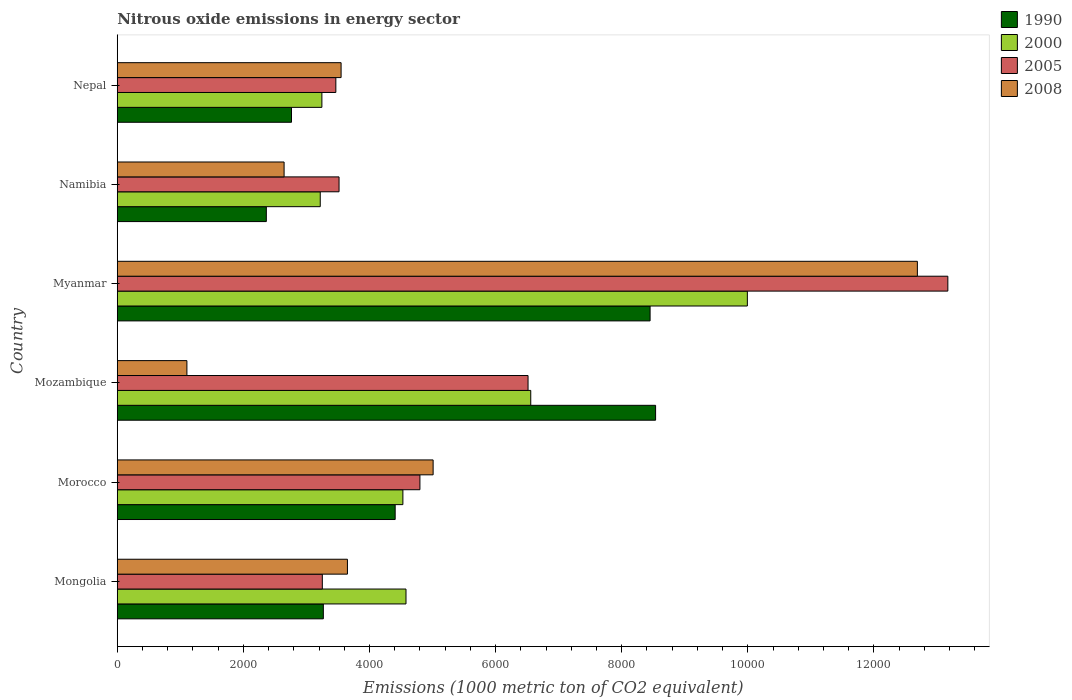How many different coloured bars are there?
Offer a terse response. 4. How many groups of bars are there?
Make the answer very short. 6. How many bars are there on the 5th tick from the top?
Your response must be concise. 4. How many bars are there on the 5th tick from the bottom?
Your answer should be compact. 4. What is the label of the 4th group of bars from the top?
Provide a short and direct response. Mozambique. What is the amount of nitrous oxide emitted in 2008 in Mozambique?
Provide a succinct answer. 1104.1. Across all countries, what is the maximum amount of nitrous oxide emitted in 2000?
Offer a very short reply. 9992.2. Across all countries, what is the minimum amount of nitrous oxide emitted in 2000?
Provide a succinct answer. 3218.7. In which country was the amount of nitrous oxide emitted in 1990 maximum?
Offer a terse response. Mozambique. In which country was the amount of nitrous oxide emitted in 1990 minimum?
Your answer should be very brief. Namibia. What is the total amount of nitrous oxide emitted in 2000 in the graph?
Your answer should be compact. 3.21e+04. What is the difference between the amount of nitrous oxide emitted in 2005 in Morocco and that in Myanmar?
Keep it short and to the point. -8372.2. What is the difference between the amount of nitrous oxide emitted in 2000 in Mozambique and the amount of nitrous oxide emitted in 1990 in Namibia?
Ensure brevity in your answer.  4193.4. What is the average amount of nitrous oxide emitted in 2008 per country?
Your answer should be compact. 4774.42. What is the difference between the amount of nitrous oxide emitted in 1990 and amount of nitrous oxide emitted in 2000 in Mongolia?
Your answer should be compact. -1310.8. In how many countries, is the amount of nitrous oxide emitted in 2005 greater than 8800 1000 metric ton?
Ensure brevity in your answer.  1. What is the ratio of the amount of nitrous oxide emitted in 2008 in Myanmar to that in Nepal?
Your answer should be compact. 3.57. Is the amount of nitrous oxide emitted in 1990 in Mongolia less than that in Namibia?
Give a very brief answer. No. What is the difference between the highest and the second highest amount of nitrous oxide emitted in 2008?
Offer a terse response. 7679.6. What is the difference between the highest and the lowest amount of nitrous oxide emitted in 1990?
Your response must be concise. 6173.2. Is the sum of the amount of nitrous oxide emitted in 1990 in Mozambique and Myanmar greater than the maximum amount of nitrous oxide emitted in 2008 across all countries?
Your response must be concise. Yes. Is it the case that in every country, the sum of the amount of nitrous oxide emitted in 1990 and amount of nitrous oxide emitted in 2005 is greater than the sum of amount of nitrous oxide emitted in 2000 and amount of nitrous oxide emitted in 2008?
Offer a terse response. No. What does the 4th bar from the top in Namibia represents?
Ensure brevity in your answer.  1990. How many bars are there?
Offer a terse response. 24. Are all the bars in the graph horizontal?
Your answer should be compact. Yes. Are the values on the major ticks of X-axis written in scientific E-notation?
Your answer should be compact. No. Does the graph contain any zero values?
Keep it short and to the point. No. How many legend labels are there?
Keep it short and to the point. 4. How are the legend labels stacked?
Provide a succinct answer. Vertical. What is the title of the graph?
Offer a terse response. Nitrous oxide emissions in energy sector. Does "1976" appear as one of the legend labels in the graph?
Keep it short and to the point. No. What is the label or title of the X-axis?
Provide a short and direct response. Emissions (1000 metric ton of CO2 equivalent). What is the label or title of the Y-axis?
Ensure brevity in your answer.  Country. What is the Emissions (1000 metric ton of CO2 equivalent) in 1990 in Mongolia?
Ensure brevity in your answer.  3267.8. What is the Emissions (1000 metric ton of CO2 equivalent) of 2000 in Mongolia?
Give a very brief answer. 4578.6. What is the Emissions (1000 metric ton of CO2 equivalent) in 2005 in Mongolia?
Give a very brief answer. 3251.9. What is the Emissions (1000 metric ton of CO2 equivalent) of 2008 in Mongolia?
Provide a succinct answer. 3650.1. What is the Emissions (1000 metric ton of CO2 equivalent) in 1990 in Morocco?
Provide a succinct answer. 4406.9. What is the Emissions (1000 metric ton of CO2 equivalent) in 2000 in Morocco?
Make the answer very short. 4529.5. What is the Emissions (1000 metric ton of CO2 equivalent) of 2005 in Morocco?
Your answer should be compact. 4799.4. What is the Emissions (1000 metric ton of CO2 equivalent) in 2008 in Morocco?
Your answer should be very brief. 5008.9. What is the Emissions (1000 metric ton of CO2 equivalent) of 1990 in Mozambique?
Offer a terse response. 8537. What is the Emissions (1000 metric ton of CO2 equivalent) in 2000 in Mozambique?
Your answer should be compact. 6557.2. What is the Emissions (1000 metric ton of CO2 equivalent) of 2005 in Mozambique?
Make the answer very short. 6514.2. What is the Emissions (1000 metric ton of CO2 equivalent) of 2008 in Mozambique?
Provide a short and direct response. 1104.1. What is the Emissions (1000 metric ton of CO2 equivalent) in 1990 in Myanmar?
Offer a very short reply. 8449.7. What is the Emissions (1000 metric ton of CO2 equivalent) of 2000 in Myanmar?
Offer a very short reply. 9992.2. What is the Emissions (1000 metric ton of CO2 equivalent) of 2005 in Myanmar?
Make the answer very short. 1.32e+04. What is the Emissions (1000 metric ton of CO2 equivalent) of 2008 in Myanmar?
Your response must be concise. 1.27e+04. What is the Emissions (1000 metric ton of CO2 equivalent) of 1990 in Namibia?
Keep it short and to the point. 2363.8. What is the Emissions (1000 metric ton of CO2 equivalent) of 2000 in Namibia?
Make the answer very short. 3218.7. What is the Emissions (1000 metric ton of CO2 equivalent) of 2005 in Namibia?
Offer a very short reply. 3516.8. What is the Emissions (1000 metric ton of CO2 equivalent) of 2008 in Namibia?
Make the answer very short. 2645.5. What is the Emissions (1000 metric ton of CO2 equivalent) of 1990 in Nepal?
Offer a very short reply. 2763. What is the Emissions (1000 metric ton of CO2 equivalent) in 2000 in Nepal?
Your response must be concise. 3244.8. What is the Emissions (1000 metric ton of CO2 equivalent) in 2005 in Nepal?
Your response must be concise. 3466.2. What is the Emissions (1000 metric ton of CO2 equivalent) of 2008 in Nepal?
Give a very brief answer. 3549.4. Across all countries, what is the maximum Emissions (1000 metric ton of CO2 equivalent) of 1990?
Provide a short and direct response. 8537. Across all countries, what is the maximum Emissions (1000 metric ton of CO2 equivalent) in 2000?
Offer a very short reply. 9992.2. Across all countries, what is the maximum Emissions (1000 metric ton of CO2 equivalent) in 2005?
Keep it short and to the point. 1.32e+04. Across all countries, what is the maximum Emissions (1000 metric ton of CO2 equivalent) of 2008?
Your answer should be very brief. 1.27e+04. Across all countries, what is the minimum Emissions (1000 metric ton of CO2 equivalent) of 1990?
Make the answer very short. 2363.8. Across all countries, what is the minimum Emissions (1000 metric ton of CO2 equivalent) in 2000?
Make the answer very short. 3218.7. Across all countries, what is the minimum Emissions (1000 metric ton of CO2 equivalent) in 2005?
Give a very brief answer. 3251.9. Across all countries, what is the minimum Emissions (1000 metric ton of CO2 equivalent) in 2008?
Provide a short and direct response. 1104.1. What is the total Emissions (1000 metric ton of CO2 equivalent) in 1990 in the graph?
Your response must be concise. 2.98e+04. What is the total Emissions (1000 metric ton of CO2 equivalent) of 2000 in the graph?
Provide a succinct answer. 3.21e+04. What is the total Emissions (1000 metric ton of CO2 equivalent) in 2005 in the graph?
Your response must be concise. 3.47e+04. What is the total Emissions (1000 metric ton of CO2 equivalent) of 2008 in the graph?
Your answer should be very brief. 2.86e+04. What is the difference between the Emissions (1000 metric ton of CO2 equivalent) in 1990 in Mongolia and that in Morocco?
Your answer should be compact. -1139.1. What is the difference between the Emissions (1000 metric ton of CO2 equivalent) of 2000 in Mongolia and that in Morocco?
Provide a succinct answer. 49.1. What is the difference between the Emissions (1000 metric ton of CO2 equivalent) in 2005 in Mongolia and that in Morocco?
Provide a short and direct response. -1547.5. What is the difference between the Emissions (1000 metric ton of CO2 equivalent) in 2008 in Mongolia and that in Morocco?
Offer a terse response. -1358.8. What is the difference between the Emissions (1000 metric ton of CO2 equivalent) in 1990 in Mongolia and that in Mozambique?
Make the answer very short. -5269.2. What is the difference between the Emissions (1000 metric ton of CO2 equivalent) in 2000 in Mongolia and that in Mozambique?
Offer a very short reply. -1978.6. What is the difference between the Emissions (1000 metric ton of CO2 equivalent) of 2005 in Mongolia and that in Mozambique?
Your answer should be very brief. -3262.3. What is the difference between the Emissions (1000 metric ton of CO2 equivalent) in 2008 in Mongolia and that in Mozambique?
Give a very brief answer. 2546. What is the difference between the Emissions (1000 metric ton of CO2 equivalent) of 1990 in Mongolia and that in Myanmar?
Keep it short and to the point. -5181.9. What is the difference between the Emissions (1000 metric ton of CO2 equivalent) of 2000 in Mongolia and that in Myanmar?
Provide a short and direct response. -5413.6. What is the difference between the Emissions (1000 metric ton of CO2 equivalent) in 2005 in Mongolia and that in Myanmar?
Your response must be concise. -9919.7. What is the difference between the Emissions (1000 metric ton of CO2 equivalent) in 2008 in Mongolia and that in Myanmar?
Make the answer very short. -9038.4. What is the difference between the Emissions (1000 metric ton of CO2 equivalent) in 1990 in Mongolia and that in Namibia?
Provide a succinct answer. 904. What is the difference between the Emissions (1000 metric ton of CO2 equivalent) in 2000 in Mongolia and that in Namibia?
Provide a short and direct response. 1359.9. What is the difference between the Emissions (1000 metric ton of CO2 equivalent) in 2005 in Mongolia and that in Namibia?
Your answer should be compact. -264.9. What is the difference between the Emissions (1000 metric ton of CO2 equivalent) of 2008 in Mongolia and that in Namibia?
Your answer should be compact. 1004.6. What is the difference between the Emissions (1000 metric ton of CO2 equivalent) in 1990 in Mongolia and that in Nepal?
Give a very brief answer. 504.8. What is the difference between the Emissions (1000 metric ton of CO2 equivalent) of 2000 in Mongolia and that in Nepal?
Your response must be concise. 1333.8. What is the difference between the Emissions (1000 metric ton of CO2 equivalent) of 2005 in Mongolia and that in Nepal?
Offer a very short reply. -214.3. What is the difference between the Emissions (1000 metric ton of CO2 equivalent) in 2008 in Mongolia and that in Nepal?
Provide a succinct answer. 100.7. What is the difference between the Emissions (1000 metric ton of CO2 equivalent) in 1990 in Morocco and that in Mozambique?
Keep it short and to the point. -4130.1. What is the difference between the Emissions (1000 metric ton of CO2 equivalent) of 2000 in Morocco and that in Mozambique?
Keep it short and to the point. -2027.7. What is the difference between the Emissions (1000 metric ton of CO2 equivalent) of 2005 in Morocco and that in Mozambique?
Keep it short and to the point. -1714.8. What is the difference between the Emissions (1000 metric ton of CO2 equivalent) of 2008 in Morocco and that in Mozambique?
Give a very brief answer. 3904.8. What is the difference between the Emissions (1000 metric ton of CO2 equivalent) of 1990 in Morocco and that in Myanmar?
Provide a short and direct response. -4042.8. What is the difference between the Emissions (1000 metric ton of CO2 equivalent) of 2000 in Morocco and that in Myanmar?
Provide a short and direct response. -5462.7. What is the difference between the Emissions (1000 metric ton of CO2 equivalent) of 2005 in Morocco and that in Myanmar?
Your answer should be compact. -8372.2. What is the difference between the Emissions (1000 metric ton of CO2 equivalent) in 2008 in Morocco and that in Myanmar?
Your response must be concise. -7679.6. What is the difference between the Emissions (1000 metric ton of CO2 equivalent) in 1990 in Morocco and that in Namibia?
Provide a succinct answer. 2043.1. What is the difference between the Emissions (1000 metric ton of CO2 equivalent) in 2000 in Morocco and that in Namibia?
Provide a short and direct response. 1310.8. What is the difference between the Emissions (1000 metric ton of CO2 equivalent) in 2005 in Morocco and that in Namibia?
Your answer should be compact. 1282.6. What is the difference between the Emissions (1000 metric ton of CO2 equivalent) of 2008 in Morocco and that in Namibia?
Make the answer very short. 2363.4. What is the difference between the Emissions (1000 metric ton of CO2 equivalent) in 1990 in Morocco and that in Nepal?
Provide a short and direct response. 1643.9. What is the difference between the Emissions (1000 metric ton of CO2 equivalent) of 2000 in Morocco and that in Nepal?
Keep it short and to the point. 1284.7. What is the difference between the Emissions (1000 metric ton of CO2 equivalent) of 2005 in Morocco and that in Nepal?
Your answer should be very brief. 1333.2. What is the difference between the Emissions (1000 metric ton of CO2 equivalent) of 2008 in Morocco and that in Nepal?
Your answer should be compact. 1459.5. What is the difference between the Emissions (1000 metric ton of CO2 equivalent) in 1990 in Mozambique and that in Myanmar?
Give a very brief answer. 87.3. What is the difference between the Emissions (1000 metric ton of CO2 equivalent) in 2000 in Mozambique and that in Myanmar?
Make the answer very short. -3435. What is the difference between the Emissions (1000 metric ton of CO2 equivalent) in 2005 in Mozambique and that in Myanmar?
Make the answer very short. -6657.4. What is the difference between the Emissions (1000 metric ton of CO2 equivalent) of 2008 in Mozambique and that in Myanmar?
Your answer should be compact. -1.16e+04. What is the difference between the Emissions (1000 metric ton of CO2 equivalent) in 1990 in Mozambique and that in Namibia?
Offer a very short reply. 6173.2. What is the difference between the Emissions (1000 metric ton of CO2 equivalent) in 2000 in Mozambique and that in Namibia?
Keep it short and to the point. 3338.5. What is the difference between the Emissions (1000 metric ton of CO2 equivalent) of 2005 in Mozambique and that in Namibia?
Offer a very short reply. 2997.4. What is the difference between the Emissions (1000 metric ton of CO2 equivalent) in 2008 in Mozambique and that in Namibia?
Ensure brevity in your answer.  -1541.4. What is the difference between the Emissions (1000 metric ton of CO2 equivalent) in 1990 in Mozambique and that in Nepal?
Offer a very short reply. 5774. What is the difference between the Emissions (1000 metric ton of CO2 equivalent) in 2000 in Mozambique and that in Nepal?
Offer a very short reply. 3312.4. What is the difference between the Emissions (1000 metric ton of CO2 equivalent) of 2005 in Mozambique and that in Nepal?
Your response must be concise. 3048. What is the difference between the Emissions (1000 metric ton of CO2 equivalent) of 2008 in Mozambique and that in Nepal?
Ensure brevity in your answer.  -2445.3. What is the difference between the Emissions (1000 metric ton of CO2 equivalent) in 1990 in Myanmar and that in Namibia?
Ensure brevity in your answer.  6085.9. What is the difference between the Emissions (1000 metric ton of CO2 equivalent) of 2000 in Myanmar and that in Namibia?
Keep it short and to the point. 6773.5. What is the difference between the Emissions (1000 metric ton of CO2 equivalent) in 2005 in Myanmar and that in Namibia?
Provide a short and direct response. 9654.8. What is the difference between the Emissions (1000 metric ton of CO2 equivalent) in 2008 in Myanmar and that in Namibia?
Offer a very short reply. 1.00e+04. What is the difference between the Emissions (1000 metric ton of CO2 equivalent) in 1990 in Myanmar and that in Nepal?
Your answer should be very brief. 5686.7. What is the difference between the Emissions (1000 metric ton of CO2 equivalent) of 2000 in Myanmar and that in Nepal?
Offer a very short reply. 6747.4. What is the difference between the Emissions (1000 metric ton of CO2 equivalent) of 2005 in Myanmar and that in Nepal?
Give a very brief answer. 9705.4. What is the difference between the Emissions (1000 metric ton of CO2 equivalent) of 2008 in Myanmar and that in Nepal?
Your answer should be compact. 9139.1. What is the difference between the Emissions (1000 metric ton of CO2 equivalent) in 1990 in Namibia and that in Nepal?
Your response must be concise. -399.2. What is the difference between the Emissions (1000 metric ton of CO2 equivalent) of 2000 in Namibia and that in Nepal?
Keep it short and to the point. -26.1. What is the difference between the Emissions (1000 metric ton of CO2 equivalent) in 2005 in Namibia and that in Nepal?
Offer a terse response. 50.6. What is the difference between the Emissions (1000 metric ton of CO2 equivalent) in 2008 in Namibia and that in Nepal?
Your answer should be very brief. -903.9. What is the difference between the Emissions (1000 metric ton of CO2 equivalent) in 1990 in Mongolia and the Emissions (1000 metric ton of CO2 equivalent) in 2000 in Morocco?
Your answer should be compact. -1261.7. What is the difference between the Emissions (1000 metric ton of CO2 equivalent) in 1990 in Mongolia and the Emissions (1000 metric ton of CO2 equivalent) in 2005 in Morocco?
Keep it short and to the point. -1531.6. What is the difference between the Emissions (1000 metric ton of CO2 equivalent) in 1990 in Mongolia and the Emissions (1000 metric ton of CO2 equivalent) in 2008 in Morocco?
Offer a very short reply. -1741.1. What is the difference between the Emissions (1000 metric ton of CO2 equivalent) of 2000 in Mongolia and the Emissions (1000 metric ton of CO2 equivalent) of 2005 in Morocco?
Provide a succinct answer. -220.8. What is the difference between the Emissions (1000 metric ton of CO2 equivalent) in 2000 in Mongolia and the Emissions (1000 metric ton of CO2 equivalent) in 2008 in Morocco?
Offer a very short reply. -430.3. What is the difference between the Emissions (1000 metric ton of CO2 equivalent) in 2005 in Mongolia and the Emissions (1000 metric ton of CO2 equivalent) in 2008 in Morocco?
Your answer should be very brief. -1757. What is the difference between the Emissions (1000 metric ton of CO2 equivalent) of 1990 in Mongolia and the Emissions (1000 metric ton of CO2 equivalent) of 2000 in Mozambique?
Make the answer very short. -3289.4. What is the difference between the Emissions (1000 metric ton of CO2 equivalent) in 1990 in Mongolia and the Emissions (1000 metric ton of CO2 equivalent) in 2005 in Mozambique?
Keep it short and to the point. -3246.4. What is the difference between the Emissions (1000 metric ton of CO2 equivalent) of 1990 in Mongolia and the Emissions (1000 metric ton of CO2 equivalent) of 2008 in Mozambique?
Provide a succinct answer. 2163.7. What is the difference between the Emissions (1000 metric ton of CO2 equivalent) of 2000 in Mongolia and the Emissions (1000 metric ton of CO2 equivalent) of 2005 in Mozambique?
Give a very brief answer. -1935.6. What is the difference between the Emissions (1000 metric ton of CO2 equivalent) in 2000 in Mongolia and the Emissions (1000 metric ton of CO2 equivalent) in 2008 in Mozambique?
Offer a terse response. 3474.5. What is the difference between the Emissions (1000 metric ton of CO2 equivalent) in 2005 in Mongolia and the Emissions (1000 metric ton of CO2 equivalent) in 2008 in Mozambique?
Offer a very short reply. 2147.8. What is the difference between the Emissions (1000 metric ton of CO2 equivalent) of 1990 in Mongolia and the Emissions (1000 metric ton of CO2 equivalent) of 2000 in Myanmar?
Provide a succinct answer. -6724.4. What is the difference between the Emissions (1000 metric ton of CO2 equivalent) of 1990 in Mongolia and the Emissions (1000 metric ton of CO2 equivalent) of 2005 in Myanmar?
Ensure brevity in your answer.  -9903.8. What is the difference between the Emissions (1000 metric ton of CO2 equivalent) in 1990 in Mongolia and the Emissions (1000 metric ton of CO2 equivalent) in 2008 in Myanmar?
Provide a succinct answer. -9420.7. What is the difference between the Emissions (1000 metric ton of CO2 equivalent) of 2000 in Mongolia and the Emissions (1000 metric ton of CO2 equivalent) of 2005 in Myanmar?
Your response must be concise. -8593. What is the difference between the Emissions (1000 metric ton of CO2 equivalent) of 2000 in Mongolia and the Emissions (1000 metric ton of CO2 equivalent) of 2008 in Myanmar?
Your response must be concise. -8109.9. What is the difference between the Emissions (1000 metric ton of CO2 equivalent) of 2005 in Mongolia and the Emissions (1000 metric ton of CO2 equivalent) of 2008 in Myanmar?
Make the answer very short. -9436.6. What is the difference between the Emissions (1000 metric ton of CO2 equivalent) of 1990 in Mongolia and the Emissions (1000 metric ton of CO2 equivalent) of 2000 in Namibia?
Offer a very short reply. 49.1. What is the difference between the Emissions (1000 metric ton of CO2 equivalent) of 1990 in Mongolia and the Emissions (1000 metric ton of CO2 equivalent) of 2005 in Namibia?
Provide a short and direct response. -249. What is the difference between the Emissions (1000 metric ton of CO2 equivalent) in 1990 in Mongolia and the Emissions (1000 metric ton of CO2 equivalent) in 2008 in Namibia?
Your answer should be compact. 622.3. What is the difference between the Emissions (1000 metric ton of CO2 equivalent) in 2000 in Mongolia and the Emissions (1000 metric ton of CO2 equivalent) in 2005 in Namibia?
Offer a terse response. 1061.8. What is the difference between the Emissions (1000 metric ton of CO2 equivalent) of 2000 in Mongolia and the Emissions (1000 metric ton of CO2 equivalent) of 2008 in Namibia?
Ensure brevity in your answer.  1933.1. What is the difference between the Emissions (1000 metric ton of CO2 equivalent) in 2005 in Mongolia and the Emissions (1000 metric ton of CO2 equivalent) in 2008 in Namibia?
Your answer should be very brief. 606.4. What is the difference between the Emissions (1000 metric ton of CO2 equivalent) in 1990 in Mongolia and the Emissions (1000 metric ton of CO2 equivalent) in 2000 in Nepal?
Offer a terse response. 23. What is the difference between the Emissions (1000 metric ton of CO2 equivalent) in 1990 in Mongolia and the Emissions (1000 metric ton of CO2 equivalent) in 2005 in Nepal?
Ensure brevity in your answer.  -198.4. What is the difference between the Emissions (1000 metric ton of CO2 equivalent) of 1990 in Mongolia and the Emissions (1000 metric ton of CO2 equivalent) of 2008 in Nepal?
Keep it short and to the point. -281.6. What is the difference between the Emissions (1000 metric ton of CO2 equivalent) of 2000 in Mongolia and the Emissions (1000 metric ton of CO2 equivalent) of 2005 in Nepal?
Make the answer very short. 1112.4. What is the difference between the Emissions (1000 metric ton of CO2 equivalent) of 2000 in Mongolia and the Emissions (1000 metric ton of CO2 equivalent) of 2008 in Nepal?
Keep it short and to the point. 1029.2. What is the difference between the Emissions (1000 metric ton of CO2 equivalent) of 2005 in Mongolia and the Emissions (1000 metric ton of CO2 equivalent) of 2008 in Nepal?
Ensure brevity in your answer.  -297.5. What is the difference between the Emissions (1000 metric ton of CO2 equivalent) of 1990 in Morocco and the Emissions (1000 metric ton of CO2 equivalent) of 2000 in Mozambique?
Your answer should be very brief. -2150.3. What is the difference between the Emissions (1000 metric ton of CO2 equivalent) in 1990 in Morocco and the Emissions (1000 metric ton of CO2 equivalent) in 2005 in Mozambique?
Your response must be concise. -2107.3. What is the difference between the Emissions (1000 metric ton of CO2 equivalent) in 1990 in Morocco and the Emissions (1000 metric ton of CO2 equivalent) in 2008 in Mozambique?
Your response must be concise. 3302.8. What is the difference between the Emissions (1000 metric ton of CO2 equivalent) in 2000 in Morocco and the Emissions (1000 metric ton of CO2 equivalent) in 2005 in Mozambique?
Offer a terse response. -1984.7. What is the difference between the Emissions (1000 metric ton of CO2 equivalent) in 2000 in Morocco and the Emissions (1000 metric ton of CO2 equivalent) in 2008 in Mozambique?
Offer a terse response. 3425.4. What is the difference between the Emissions (1000 metric ton of CO2 equivalent) of 2005 in Morocco and the Emissions (1000 metric ton of CO2 equivalent) of 2008 in Mozambique?
Your answer should be compact. 3695.3. What is the difference between the Emissions (1000 metric ton of CO2 equivalent) of 1990 in Morocco and the Emissions (1000 metric ton of CO2 equivalent) of 2000 in Myanmar?
Provide a succinct answer. -5585.3. What is the difference between the Emissions (1000 metric ton of CO2 equivalent) in 1990 in Morocco and the Emissions (1000 metric ton of CO2 equivalent) in 2005 in Myanmar?
Offer a very short reply. -8764.7. What is the difference between the Emissions (1000 metric ton of CO2 equivalent) of 1990 in Morocco and the Emissions (1000 metric ton of CO2 equivalent) of 2008 in Myanmar?
Offer a very short reply. -8281.6. What is the difference between the Emissions (1000 metric ton of CO2 equivalent) in 2000 in Morocco and the Emissions (1000 metric ton of CO2 equivalent) in 2005 in Myanmar?
Provide a succinct answer. -8642.1. What is the difference between the Emissions (1000 metric ton of CO2 equivalent) of 2000 in Morocco and the Emissions (1000 metric ton of CO2 equivalent) of 2008 in Myanmar?
Your answer should be compact. -8159. What is the difference between the Emissions (1000 metric ton of CO2 equivalent) in 2005 in Morocco and the Emissions (1000 metric ton of CO2 equivalent) in 2008 in Myanmar?
Provide a short and direct response. -7889.1. What is the difference between the Emissions (1000 metric ton of CO2 equivalent) in 1990 in Morocco and the Emissions (1000 metric ton of CO2 equivalent) in 2000 in Namibia?
Your response must be concise. 1188.2. What is the difference between the Emissions (1000 metric ton of CO2 equivalent) of 1990 in Morocco and the Emissions (1000 metric ton of CO2 equivalent) of 2005 in Namibia?
Offer a terse response. 890.1. What is the difference between the Emissions (1000 metric ton of CO2 equivalent) in 1990 in Morocco and the Emissions (1000 metric ton of CO2 equivalent) in 2008 in Namibia?
Offer a very short reply. 1761.4. What is the difference between the Emissions (1000 metric ton of CO2 equivalent) of 2000 in Morocco and the Emissions (1000 metric ton of CO2 equivalent) of 2005 in Namibia?
Provide a short and direct response. 1012.7. What is the difference between the Emissions (1000 metric ton of CO2 equivalent) in 2000 in Morocco and the Emissions (1000 metric ton of CO2 equivalent) in 2008 in Namibia?
Offer a terse response. 1884. What is the difference between the Emissions (1000 metric ton of CO2 equivalent) in 2005 in Morocco and the Emissions (1000 metric ton of CO2 equivalent) in 2008 in Namibia?
Make the answer very short. 2153.9. What is the difference between the Emissions (1000 metric ton of CO2 equivalent) of 1990 in Morocco and the Emissions (1000 metric ton of CO2 equivalent) of 2000 in Nepal?
Your answer should be very brief. 1162.1. What is the difference between the Emissions (1000 metric ton of CO2 equivalent) of 1990 in Morocco and the Emissions (1000 metric ton of CO2 equivalent) of 2005 in Nepal?
Keep it short and to the point. 940.7. What is the difference between the Emissions (1000 metric ton of CO2 equivalent) in 1990 in Morocco and the Emissions (1000 metric ton of CO2 equivalent) in 2008 in Nepal?
Make the answer very short. 857.5. What is the difference between the Emissions (1000 metric ton of CO2 equivalent) of 2000 in Morocco and the Emissions (1000 metric ton of CO2 equivalent) of 2005 in Nepal?
Provide a short and direct response. 1063.3. What is the difference between the Emissions (1000 metric ton of CO2 equivalent) of 2000 in Morocco and the Emissions (1000 metric ton of CO2 equivalent) of 2008 in Nepal?
Offer a very short reply. 980.1. What is the difference between the Emissions (1000 metric ton of CO2 equivalent) in 2005 in Morocco and the Emissions (1000 metric ton of CO2 equivalent) in 2008 in Nepal?
Your answer should be very brief. 1250. What is the difference between the Emissions (1000 metric ton of CO2 equivalent) in 1990 in Mozambique and the Emissions (1000 metric ton of CO2 equivalent) in 2000 in Myanmar?
Your answer should be compact. -1455.2. What is the difference between the Emissions (1000 metric ton of CO2 equivalent) in 1990 in Mozambique and the Emissions (1000 metric ton of CO2 equivalent) in 2005 in Myanmar?
Your response must be concise. -4634.6. What is the difference between the Emissions (1000 metric ton of CO2 equivalent) of 1990 in Mozambique and the Emissions (1000 metric ton of CO2 equivalent) of 2008 in Myanmar?
Make the answer very short. -4151.5. What is the difference between the Emissions (1000 metric ton of CO2 equivalent) in 2000 in Mozambique and the Emissions (1000 metric ton of CO2 equivalent) in 2005 in Myanmar?
Your response must be concise. -6614.4. What is the difference between the Emissions (1000 metric ton of CO2 equivalent) of 2000 in Mozambique and the Emissions (1000 metric ton of CO2 equivalent) of 2008 in Myanmar?
Make the answer very short. -6131.3. What is the difference between the Emissions (1000 metric ton of CO2 equivalent) of 2005 in Mozambique and the Emissions (1000 metric ton of CO2 equivalent) of 2008 in Myanmar?
Offer a terse response. -6174.3. What is the difference between the Emissions (1000 metric ton of CO2 equivalent) of 1990 in Mozambique and the Emissions (1000 metric ton of CO2 equivalent) of 2000 in Namibia?
Your response must be concise. 5318.3. What is the difference between the Emissions (1000 metric ton of CO2 equivalent) of 1990 in Mozambique and the Emissions (1000 metric ton of CO2 equivalent) of 2005 in Namibia?
Your answer should be very brief. 5020.2. What is the difference between the Emissions (1000 metric ton of CO2 equivalent) of 1990 in Mozambique and the Emissions (1000 metric ton of CO2 equivalent) of 2008 in Namibia?
Offer a terse response. 5891.5. What is the difference between the Emissions (1000 metric ton of CO2 equivalent) in 2000 in Mozambique and the Emissions (1000 metric ton of CO2 equivalent) in 2005 in Namibia?
Your response must be concise. 3040.4. What is the difference between the Emissions (1000 metric ton of CO2 equivalent) of 2000 in Mozambique and the Emissions (1000 metric ton of CO2 equivalent) of 2008 in Namibia?
Your response must be concise. 3911.7. What is the difference between the Emissions (1000 metric ton of CO2 equivalent) in 2005 in Mozambique and the Emissions (1000 metric ton of CO2 equivalent) in 2008 in Namibia?
Your response must be concise. 3868.7. What is the difference between the Emissions (1000 metric ton of CO2 equivalent) of 1990 in Mozambique and the Emissions (1000 metric ton of CO2 equivalent) of 2000 in Nepal?
Provide a short and direct response. 5292.2. What is the difference between the Emissions (1000 metric ton of CO2 equivalent) in 1990 in Mozambique and the Emissions (1000 metric ton of CO2 equivalent) in 2005 in Nepal?
Your answer should be compact. 5070.8. What is the difference between the Emissions (1000 metric ton of CO2 equivalent) in 1990 in Mozambique and the Emissions (1000 metric ton of CO2 equivalent) in 2008 in Nepal?
Your answer should be very brief. 4987.6. What is the difference between the Emissions (1000 metric ton of CO2 equivalent) in 2000 in Mozambique and the Emissions (1000 metric ton of CO2 equivalent) in 2005 in Nepal?
Ensure brevity in your answer.  3091. What is the difference between the Emissions (1000 metric ton of CO2 equivalent) in 2000 in Mozambique and the Emissions (1000 metric ton of CO2 equivalent) in 2008 in Nepal?
Offer a terse response. 3007.8. What is the difference between the Emissions (1000 metric ton of CO2 equivalent) of 2005 in Mozambique and the Emissions (1000 metric ton of CO2 equivalent) of 2008 in Nepal?
Provide a short and direct response. 2964.8. What is the difference between the Emissions (1000 metric ton of CO2 equivalent) in 1990 in Myanmar and the Emissions (1000 metric ton of CO2 equivalent) in 2000 in Namibia?
Ensure brevity in your answer.  5231. What is the difference between the Emissions (1000 metric ton of CO2 equivalent) in 1990 in Myanmar and the Emissions (1000 metric ton of CO2 equivalent) in 2005 in Namibia?
Ensure brevity in your answer.  4932.9. What is the difference between the Emissions (1000 metric ton of CO2 equivalent) of 1990 in Myanmar and the Emissions (1000 metric ton of CO2 equivalent) of 2008 in Namibia?
Make the answer very short. 5804.2. What is the difference between the Emissions (1000 metric ton of CO2 equivalent) of 2000 in Myanmar and the Emissions (1000 metric ton of CO2 equivalent) of 2005 in Namibia?
Your answer should be compact. 6475.4. What is the difference between the Emissions (1000 metric ton of CO2 equivalent) in 2000 in Myanmar and the Emissions (1000 metric ton of CO2 equivalent) in 2008 in Namibia?
Provide a succinct answer. 7346.7. What is the difference between the Emissions (1000 metric ton of CO2 equivalent) of 2005 in Myanmar and the Emissions (1000 metric ton of CO2 equivalent) of 2008 in Namibia?
Make the answer very short. 1.05e+04. What is the difference between the Emissions (1000 metric ton of CO2 equivalent) of 1990 in Myanmar and the Emissions (1000 metric ton of CO2 equivalent) of 2000 in Nepal?
Make the answer very short. 5204.9. What is the difference between the Emissions (1000 metric ton of CO2 equivalent) of 1990 in Myanmar and the Emissions (1000 metric ton of CO2 equivalent) of 2005 in Nepal?
Give a very brief answer. 4983.5. What is the difference between the Emissions (1000 metric ton of CO2 equivalent) of 1990 in Myanmar and the Emissions (1000 metric ton of CO2 equivalent) of 2008 in Nepal?
Offer a very short reply. 4900.3. What is the difference between the Emissions (1000 metric ton of CO2 equivalent) in 2000 in Myanmar and the Emissions (1000 metric ton of CO2 equivalent) in 2005 in Nepal?
Offer a terse response. 6526. What is the difference between the Emissions (1000 metric ton of CO2 equivalent) in 2000 in Myanmar and the Emissions (1000 metric ton of CO2 equivalent) in 2008 in Nepal?
Your response must be concise. 6442.8. What is the difference between the Emissions (1000 metric ton of CO2 equivalent) of 2005 in Myanmar and the Emissions (1000 metric ton of CO2 equivalent) of 2008 in Nepal?
Ensure brevity in your answer.  9622.2. What is the difference between the Emissions (1000 metric ton of CO2 equivalent) of 1990 in Namibia and the Emissions (1000 metric ton of CO2 equivalent) of 2000 in Nepal?
Provide a succinct answer. -881. What is the difference between the Emissions (1000 metric ton of CO2 equivalent) in 1990 in Namibia and the Emissions (1000 metric ton of CO2 equivalent) in 2005 in Nepal?
Give a very brief answer. -1102.4. What is the difference between the Emissions (1000 metric ton of CO2 equivalent) of 1990 in Namibia and the Emissions (1000 metric ton of CO2 equivalent) of 2008 in Nepal?
Offer a terse response. -1185.6. What is the difference between the Emissions (1000 metric ton of CO2 equivalent) in 2000 in Namibia and the Emissions (1000 metric ton of CO2 equivalent) in 2005 in Nepal?
Your answer should be compact. -247.5. What is the difference between the Emissions (1000 metric ton of CO2 equivalent) of 2000 in Namibia and the Emissions (1000 metric ton of CO2 equivalent) of 2008 in Nepal?
Provide a succinct answer. -330.7. What is the difference between the Emissions (1000 metric ton of CO2 equivalent) in 2005 in Namibia and the Emissions (1000 metric ton of CO2 equivalent) in 2008 in Nepal?
Give a very brief answer. -32.6. What is the average Emissions (1000 metric ton of CO2 equivalent) in 1990 per country?
Give a very brief answer. 4964.7. What is the average Emissions (1000 metric ton of CO2 equivalent) of 2000 per country?
Keep it short and to the point. 5353.5. What is the average Emissions (1000 metric ton of CO2 equivalent) in 2005 per country?
Your answer should be compact. 5786.68. What is the average Emissions (1000 metric ton of CO2 equivalent) of 2008 per country?
Offer a terse response. 4774.42. What is the difference between the Emissions (1000 metric ton of CO2 equivalent) of 1990 and Emissions (1000 metric ton of CO2 equivalent) of 2000 in Mongolia?
Your answer should be compact. -1310.8. What is the difference between the Emissions (1000 metric ton of CO2 equivalent) of 1990 and Emissions (1000 metric ton of CO2 equivalent) of 2008 in Mongolia?
Offer a terse response. -382.3. What is the difference between the Emissions (1000 metric ton of CO2 equivalent) of 2000 and Emissions (1000 metric ton of CO2 equivalent) of 2005 in Mongolia?
Ensure brevity in your answer.  1326.7. What is the difference between the Emissions (1000 metric ton of CO2 equivalent) in 2000 and Emissions (1000 metric ton of CO2 equivalent) in 2008 in Mongolia?
Provide a short and direct response. 928.5. What is the difference between the Emissions (1000 metric ton of CO2 equivalent) in 2005 and Emissions (1000 metric ton of CO2 equivalent) in 2008 in Mongolia?
Make the answer very short. -398.2. What is the difference between the Emissions (1000 metric ton of CO2 equivalent) in 1990 and Emissions (1000 metric ton of CO2 equivalent) in 2000 in Morocco?
Provide a short and direct response. -122.6. What is the difference between the Emissions (1000 metric ton of CO2 equivalent) in 1990 and Emissions (1000 metric ton of CO2 equivalent) in 2005 in Morocco?
Your answer should be very brief. -392.5. What is the difference between the Emissions (1000 metric ton of CO2 equivalent) in 1990 and Emissions (1000 metric ton of CO2 equivalent) in 2008 in Morocco?
Ensure brevity in your answer.  -602. What is the difference between the Emissions (1000 metric ton of CO2 equivalent) in 2000 and Emissions (1000 metric ton of CO2 equivalent) in 2005 in Morocco?
Provide a short and direct response. -269.9. What is the difference between the Emissions (1000 metric ton of CO2 equivalent) in 2000 and Emissions (1000 metric ton of CO2 equivalent) in 2008 in Morocco?
Keep it short and to the point. -479.4. What is the difference between the Emissions (1000 metric ton of CO2 equivalent) in 2005 and Emissions (1000 metric ton of CO2 equivalent) in 2008 in Morocco?
Offer a terse response. -209.5. What is the difference between the Emissions (1000 metric ton of CO2 equivalent) in 1990 and Emissions (1000 metric ton of CO2 equivalent) in 2000 in Mozambique?
Ensure brevity in your answer.  1979.8. What is the difference between the Emissions (1000 metric ton of CO2 equivalent) of 1990 and Emissions (1000 metric ton of CO2 equivalent) of 2005 in Mozambique?
Make the answer very short. 2022.8. What is the difference between the Emissions (1000 metric ton of CO2 equivalent) in 1990 and Emissions (1000 metric ton of CO2 equivalent) in 2008 in Mozambique?
Offer a terse response. 7432.9. What is the difference between the Emissions (1000 metric ton of CO2 equivalent) of 2000 and Emissions (1000 metric ton of CO2 equivalent) of 2005 in Mozambique?
Offer a very short reply. 43. What is the difference between the Emissions (1000 metric ton of CO2 equivalent) of 2000 and Emissions (1000 metric ton of CO2 equivalent) of 2008 in Mozambique?
Your response must be concise. 5453.1. What is the difference between the Emissions (1000 metric ton of CO2 equivalent) in 2005 and Emissions (1000 metric ton of CO2 equivalent) in 2008 in Mozambique?
Your response must be concise. 5410.1. What is the difference between the Emissions (1000 metric ton of CO2 equivalent) in 1990 and Emissions (1000 metric ton of CO2 equivalent) in 2000 in Myanmar?
Provide a succinct answer. -1542.5. What is the difference between the Emissions (1000 metric ton of CO2 equivalent) of 1990 and Emissions (1000 metric ton of CO2 equivalent) of 2005 in Myanmar?
Your answer should be compact. -4721.9. What is the difference between the Emissions (1000 metric ton of CO2 equivalent) in 1990 and Emissions (1000 metric ton of CO2 equivalent) in 2008 in Myanmar?
Your response must be concise. -4238.8. What is the difference between the Emissions (1000 metric ton of CO2 equivalent) of 2000 and Emissions (1000 metric ton of CO2 equivalent) of 2005 in Myanmar?
Provide a short and direct response. -3179.4. What is the difference between the Emissions (1000 metric ton of CO2 equivalent) in 2000 and Emissions (1000 metric ton of CO2 equivalent) in 2008 in Myanmar?
Make the answer very short. -2696.3. What is the difference between the Emissions (1000 metric ton of CO2 equivalent) of 2005 and Emissions (1000 metric ton of CO2 equivalent) of 2008 in Myanmar?
Your answer should be compact. 483.1. What is the difference between the Emissions (1000 metric ton of CO2 equivalent) of 1990 and Emissions (1000 metric ton of CO2 equivalent) of 2000 in Namibia?
Make the answer very short. -854.9. What is the difference between the Emissions (1000 metric ton of CO2 equivalent) in 1990 and Emissions (1000 metric ton of CO2 equivalent) in 2005 in Namibia?
Give a very brief answer. -1153. What is the difference between the Emissions (1000 metric ton of CO2 equivalent) of 1990 and Emissions (1000 metric ton of CO2 equivalent) of 2008 in Namibia?
Offer a terse response. -281.7. What is the difference between the Emissions (1000 metric ton of CO2 equivalent) in 2000 and Emissions (1000 metric ton of CO2 equivalent) in 2005 in Namibia?
Offer a terse response. -298.1. What is the difference between the Emissions (1000 metric ton of CO2 equivalent) of 2000 and Emissions (1000 metric ton of CO2 equivalent) of 2008 in Namibia?
Your answer should be compact. 573.2. What is the difference between the Emissions (1000 metric ton of CO2 equivalent) in 2005 and Emissions (1000 metric ton of CO2 equivalent) in 2008 in Namibia?
Your answer should be very brief. 871.3. What is the difference between the Emissions (1000 metric ton of CO2 equivalent) of 1990 and Emissions (1000 metric ton of CO2 equivalent) of 2000 in Nepal?
Provide a succinct answer. -481.8. What is the difference between the Emissions (1000 metric ton of CO2 equivalent) of 1990 and Emissions (1000 metric ton of CO2 equivalent) of 2005 in Nepal?
Offer a terse response. -703.2. What is the difference between the Emissions (1000 metric ton of CO2 equivalent) of 1990 and Emissions (1000 metric ton of CO2 equivalent) of 2008 in Nepal?
Your answer should be very brief. -786.4. What is the difference between the Emissions (1000 metric ton of CO2 equivalent) in 2000 and Emissions (1000 metric ton of CO2 equivalent) in 2005 in Nepal?
Ensure brevity in your answer.  -221.4. What is the difference between the Emissions (1000 metric ton of CO2 equivalent) in 2000 and Emissions (1000 metric ton of CO2 equivalent) in 2008 in Nepal?
Your answer should be compact. -304.6. What is the difference between the Emissions (1000 metric ton of CO2 equivalent) of 2005 and Emissions (1000 metric ton of CO2 equivalent) of 2008 in Nepal?
Your response must be concise. -83.2. What is the ratio of the Emissions (1000 metric ton of CO2 equivalent) in 1990 in Mongolia to that in Morocco?
Ensure brevity in your answer.  0.74. What is the ratio of the Emissions (1000 metric ton of CO2 equivalent) of 2000 in Mongolia to that in Morocco?
Provide a succinct answer. 1.01. What is the ratio of the Emissions (1000 metric ton of CO2 equivalent) in 2005 in Mongolia to that in Morocco?
Your response must be concise. 0.68. What is the ratio of the Emissions (1000 metric ton of CO2 equivalent) in 2008 in Mongolia to that in Morocco?
Give a very brief answer. 0.73. What is the ratio of the Emissions (1000 metric ton of CO2 equivalent) in 1990 in Mongolia to that in Mozambique?
Offer a terse response. 0.38. What is the ratio of the Emissions (1000 metric ton of CO2 equivalent) of 2000 in Mongolia to that in Mozambique?
Ensure brevity in your answer.  0.7. What is the ratio of the Emissions (1000 metric ton of CO2 equivalent) in 2005 in Mongolia to that in Mozambique?
Provide a succinct answer. 0.5. What is the ratio of the Emissions (1000 metric ton of CO2 equivalent) in 2008 in Mongolia to that in Mozambique?
Offer a terse response. 3.31. What is the ratio of the Emissions (1000 metric ton of CO2 equivalent) of 1990 in Mongolia to that in Myanmar?
Offer a very short reply. 0.39. What is the ratio of the Emissions (1000 metric ton of CO2 equivalent) in 2000 in Mongolia to that in Myanmar?
Your response must be concise. 0.46. What is the ratio of the Emissions (1000 metric ton of CO2 equivalent) in 2005 in Mongolia to that in Myanmar?
Offer a terse response. 0.25. What is the ratio of the Emissions (1000 metric ton of CO2 equivalent) in 2008 in Mongolia to that in Myanmar?
Provide a short and direct response. 0.29. What is the ratio of the Emissions (1000 metric ton of CO2 equivalent) of 1990 in Mongolia to that in Namibia?
Give a very brief answer. 1.38. What is the ratio of the Emissions (1000 metric ton of CO2 equivalent) in 2000 in Mongolia to that in Namibia?
Give a very brief answer. 1.42. What is the ratio of the Emissions (1000 metric ton of CO2 equivalent) in 2005 in Mongolia to that in Namibia?
Your answer should be compact. 0.92. What is the ratio of the Emissions (1000 metric ton of CO2 equivalent) of 2008 in Mongolia to that in Namibia?
Ensure brevity in your answer.  1.38. What is the ratio of the Emissions (1000 metric ton of CO2 equivalent) in 1990 in Mongolia to that in Nepal?
Your answer should be very brief. 1.18. What is the ratio of the Emissions (1000 metric ton of CO2 equivalent) of 2000 in Mongolia to that in Nepal?
Keep it short and to the point. 1.41. What is the ratio of the Emissions (1000 metric ton of CO2 equivalent) of 2005 in Mongolia to that in Nepal?
Give a very brief answer. 0.94. What is the ratio of the Emissions (1000 metric ton of CO2 equivalent) in 2008 in Mongolia to that in Nepal?
Give a very brief answer. 1.03. What is the ratio of the Emissions (1000 metric ton of CO2 equivalent) in 1990 in Morocco to that in Mozambique?
Provide a succinct answer. 0.52. What is the ratio of the Emissions (1000 metric ton of CO2 equivalent) in 2000 in Morocco to that in Mozambique?
Your answer should be compact. 0.69. What is the ratio of the Emissions (1000 metric ton of CO2 equivalent) in 2005 in Morocco to that in Mozambique?
Offer a very short reply. 0.74. What is the ratio of the Emissions (1000 metric ton of CO2 equivalent) of 2008 in Morocco to that in Mozambique?
Provide a succinct answer. 4.54. What is the ratio of the Emissions (1000 metric ton of CO2 equivalent) of 1990 in Morocco to that in Myanmar?
Your response must be concise. 0.52. What is the ratio of the Emissions (1000 metric ton of CO2 equivalent) in 2000 in Morocco to that in Myanmar?
Ensure brevity in your answer.  0.45. What is the ratio of the Emissions (1000 metric ton of CO2 equivalent) of 2005 in Morocco to that in Myanmar?
Your response must be concise. 0.36. What is the ratio of the Emissions (1000 metric ton of CO2 equivalent) of 2008 in Morocco to that in Myanmar?
Ensure brevity in your answer.  0.39. What is the ratio of the Emissions (1000 metric ton of CO2 equivalent) in 1990 in Morocco to that in Namibia?
Keep it short and to the point. 1.86. What is the ratio of the Emissions (1000 metric ton of CO2 equivalent) in 2000 in Morocco to that in Namibia?
Offer a terse response. 1.41. What is the ratio of the Emissions (1000 metric ton of CO2 equivalent) in 2005 in Morocco to that in Namibia?
Provide a short and direct response. 1.36. What is the ratio of the Emissions (1000 metric ton of CO2 equivalent) in 2008 in Morocco to that in Namibia?
Keep it short and to the point. 1.89. What is the ratio of the Emissions (1000 metric ton of CO2 equivalent) of 1990 in Morocco to that in Nepal?
Keep it short and to the point. 1.59. What is the ratio of the Emissions (1000 metric ton of CO2 equivalent) of 2000 in Morocco to that in Nepal?
Your answer should be very brief. 1.4. What is the ratio of the Emissions (1000 metric ton of CO2 equivalent) of 2005 in Morocco to that in Nepal?
Provide a succinct answer. 1.38. What is the ratio of the Emissions (1000 metric ton of CO2 equivalent) of 2008 in Morocco to that in Nepal?
Ensure brevity in your answer.  1.41. What is the ratio of the Emissions (1000 metric ton of CO2 equivalent) of 1990 in Mozambique to that in Myanmar?
Ensure brevity in your answer.  1.01. What is the ratio of the Emissions (1000 metric ton of CO2 equivalent) of 2000 in Mozambique to that in Myanmar?
Provide a short and direct response. 0.66. What is the ratio of the Emissions (1000 metric ton of CO2 equivalent) of 2005 in Mozambique to that in Myanmar?
Give a very brief answer. 0.49. What is the ratio of the Emissions (1000 metric ton of CO2 equivalent) of 2008 in Mozambique to that in Myanmar?
Ensure brevity in your answer.  0.09. What is the ratio of the Emissions (1000 metric ton of CO2 equivalent) in 1990 in Mozambique to that in Namibia?
Ensure brevity in your answer.  3.61. What is the ratio of the Emissions (1000 metric ton of CO2 equivalent) in 2000 in Mozambique to that in Namibia?
Provide a short and direct response. 2.04. What is the ratio of the Emissions (1000 metric ton of CO2 equivalent) in 2005 in Mozambique to that in Namibia?
Give a very brief answer. 1.85. What is the ratio of the Emissions (1000 metric ton of CO2 equivalent) of 2008 in Mozambique to that in Namibia?
Provide a short and direct response. 0.42. What is the ratio of the Emissions (1000 metric ton of CO2 equivalent) in 1990 in Mozambique to that in Nepal?
Your answer should be very brief. 3.09. What is the ratio of the Emissions (1000 metric ton of CO2 equivalent) of 2000 in Mozambique to that in Nepal?
Ensure brevity in your answer.  2.02. What is the ratio of the Emissions (1000 metric ton of CO2 equivalent) of 2005 in Mozambique to that in Nepal?
Ensure brevity in your answer.  1.88. What is the ratio of the Emissions (1000 metric ton of CO2 equivalent) in 2008 in Mozambique to that in Nepal?
Your response must be concise. 0.31. What is the ratio of the Emissions (1000 metric ton of CO2 equivalent) in 1990 in Myanmar to that in Namibia?
Ensure brevity in your answer.  3.57. What is the ratio of the Emissions (1000 metric ton of CO2 equivalent) of 2000 in Myanmar to that in Namibia?
Provide a short and direct response. 3.1. What is the ratio of the Emissions (1000 metric ton of CO2 equivalent) of 2005 in Myanmar to that in Namibia?
Keep it short and to the point. 3.75. What is the ratio of the Emissions (1000 metric ton of CO2 equivalent) in 2008 in Myanmar to that in Namibia?
Give a very brief answer. 4.8. What is the ratio of the Emissions (1000 metric ton of CO2 equivalent) in 1990 in Myanmar to that in Nepal?
Provide a succinct answer. 3.06. What is the ratio of the Emissions (1000 metric ton of CO2 equivalent) in 2000 in Myanmar to that in Nepal?
Provide a short and direct response. 3.08. What is the ratio of the Emissions (1000 metric ton of CO2 equivalent) of 2005 in Myanmar to that in Nepal?
Your response must be concise. 3.8. What is the ratio of the Emissions (1000 metric ton of CO2 equivalent) of 2008 in Myanmar to that in Nepal?
Your answer should be very brief. 3.57. What is the ratio of the Emissions (1000 metric ton of CO2 equivalent) in 1990 in Namibia to that in Nepal?
Make the answer very short. 0.86. What is the ratio of the Emissions (1000 metric ton of CO2 equivalent) of 2000 in Namibia to that in Nepal?
Your response must be concise. 0.99. What is the ratio of the Emissions (1000 metric ton of CO2 equivalent) in 2005 in Namibia to that in Nepal?
Ensure brevity in your answer.  1.01. What is the ratio of the Emissions (1000 metric ton of CO2 equivalent) of 2008 in Namibia to that in Nepal?
Provide a succinct answer. 0.75. What is the difference between the highest and the second highest Emissions (1000 metric ton of CO2 equivalent) of 1990?
Make the answer very short. 87.3. What is the difference between the highest and the second highest Emissions (1000 metric ton of CO2 equivalent) in 2000?
Offer a terse response. 3435. What is the difference between the highest and the second highest Emissions (1000 metric ton of CO2 equivalent) of 2005?
Offer a terse response. 6657.4. What is the difference between the highest and the second highest Emissions (1000 metric ton of CO2 equivalent) in 2008?
Offer a very short reply. 7679.6. What is the difference between the highest and the lowest Emissions (1000 metric ton of CO2 equivalent) in 1990?
Your answer should be very brief. 6173.2. What is the difference between the highest and the lowest Emissions (1000 metric ton of CO2 equivalent) in 2000?
Provide a short and direct response. 6773.5. What is the difference between the highest and the lowest Emissions (1000 metric ton of CO2 equivalent) of 2005?
Ensure brevity in your answer.  9919.7. What is the difference between the highest and the lowest Emissions (1000 metric ton of CO2 equivalent) of 2008?
Provide a succinct answer. 1.16e+04. 